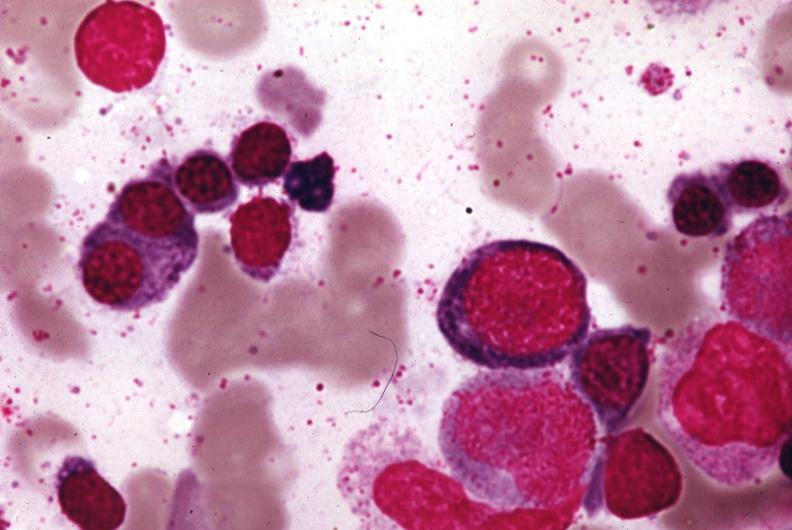s hematologic present?
Answer the question using a single word or phrase. Yes 